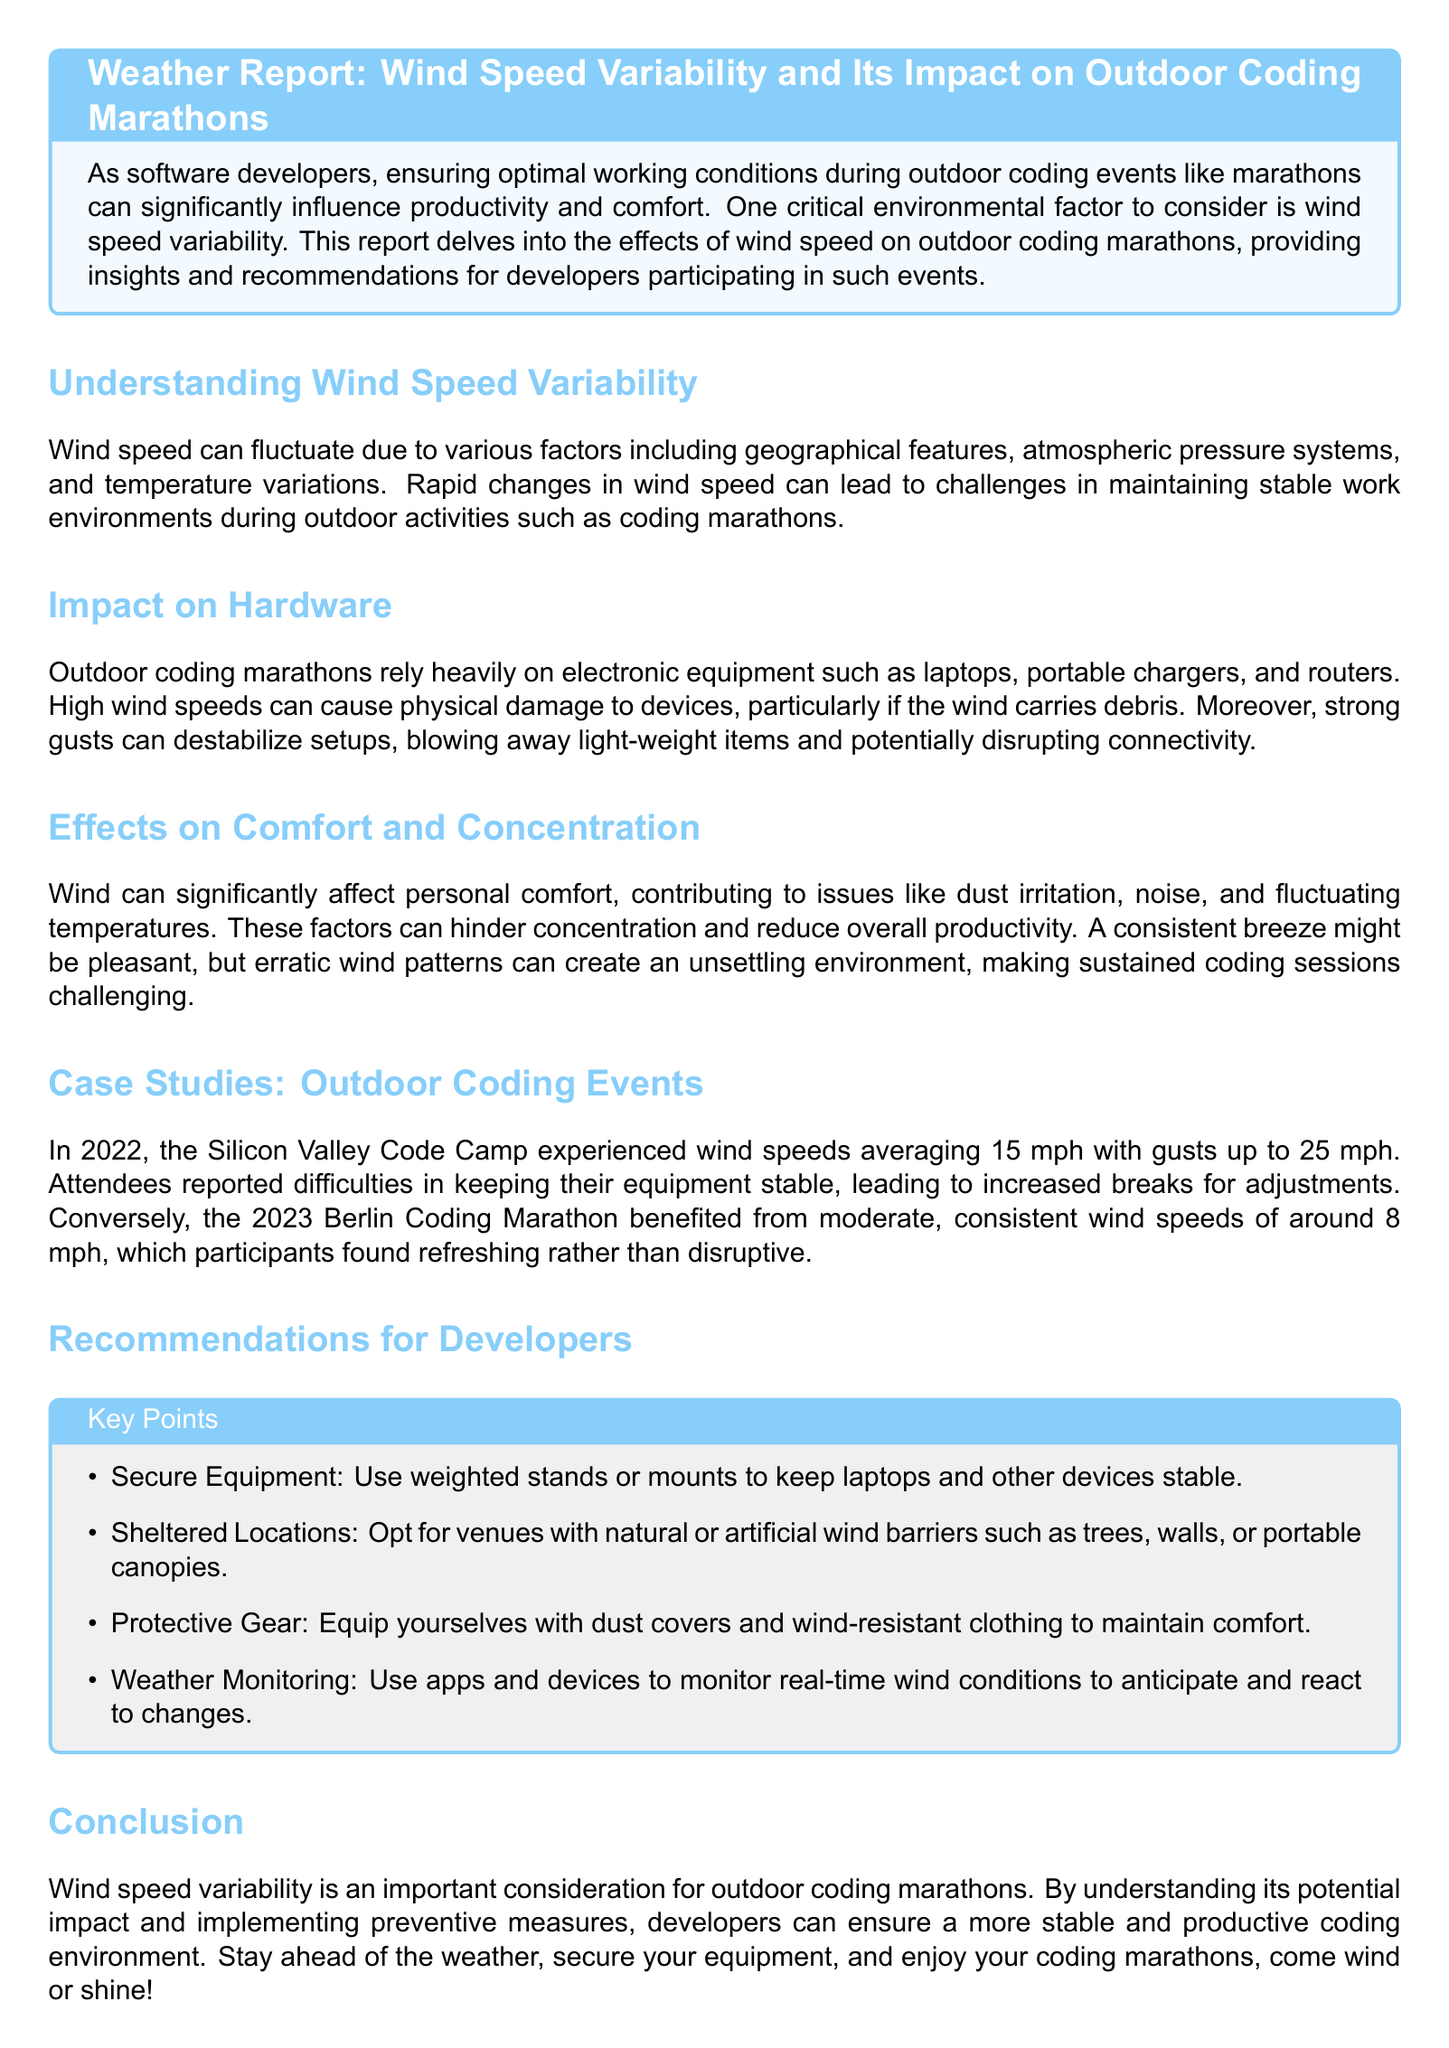What is the average wind speed at the Silicon Valley Code Camp? The document mentions that the Silicon Valley Code Camp experienced wind speeds averaging 15 mph.
Answer: 15 mph What wind speed was recorded at the Berlin Coding Marathon? According to the document, the Berlin Coding Marathon benefited from wind speeds of around 8 mph.
Answer: 8 mph What is one equipment stability recommendation for outdoor coding? The recommendations section suggests using weighted stands or mounts to keep laptops and other devices stable.
Answer: Weighted stands What year did the Silicon Valley Code Camp take place? The report indicates that the Silicon Valley Code Camp occurred in 2022.
Answer: 2022 What is a comfort issue caused by wind during coding marathons? The document states that wind can contribute to dust irritation, which affects personal comfort.
Answer: Dust irritation Which elements can help secure equipment from wind? The report suggests using natural or artificial wind barriers like trees, walls, or portable canopies.
Answer: Wind barriers Why can erratic wind patterns hinder coding sessions? The document explains that erratic wind patterns create an unsettling environment, making sustained coding challenging.
Answer: Unsettling environment What is an effect of high wind speeds on electronic equipment? High wind speeds can cause physical damage to devices and disrupt connectivity due to destabilization.
Answer: Physical damage What year did the Berlin Coding Marathon occur? The document mentions the Berlin Coding Marathon took place in 2023.
Answer: 2023 